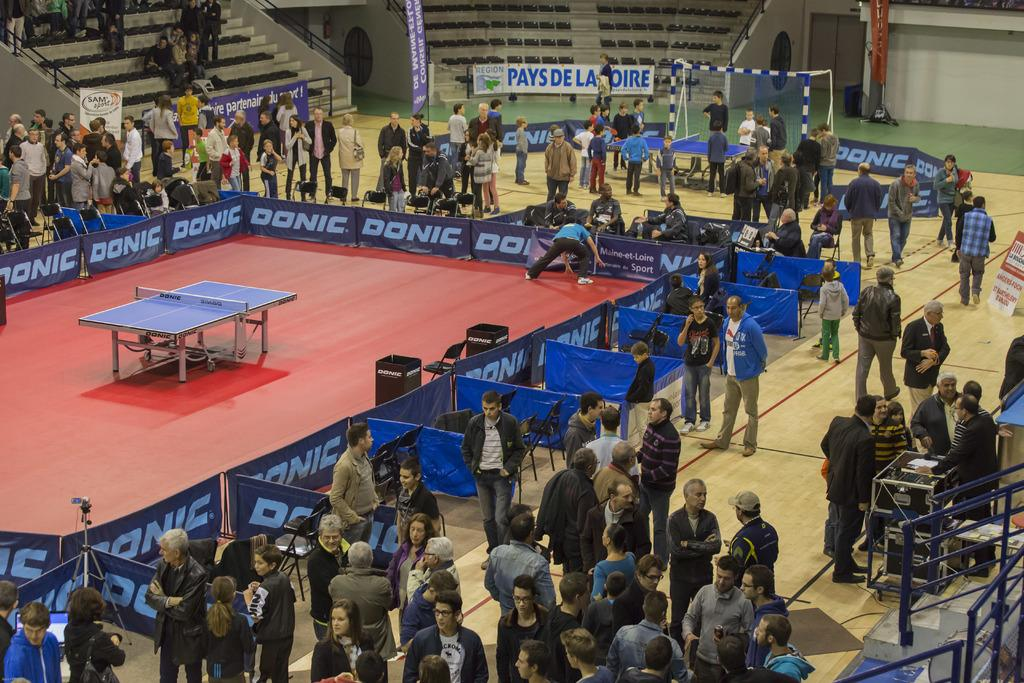What is the main activity taking place in the image? There is a group of people standing in the image, which suggests they might be participating in an activity or event. What type of facility is depicted in the image? There is a table tennis center in the image. Are there any signs or advertisements visible in the image? Yes, there are banners and hoardings in the image. What type of furniture is present in the image? There are chairs in the image. What can be seen on the floor in the image? The floor is visible in the image. What type of pump is being used to inflate the banners in the image? There is no pump present in the image, and the banners do not appear to be inflated. How many clovers are visible on the floor in the image? There are no clovers present in the image; the floor is visible but does not have any plants or objects on it. 